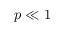Convert formula to latex. <formula><loc_0><loc_0><loc_500><loc_500>p \ll 1</formula> 